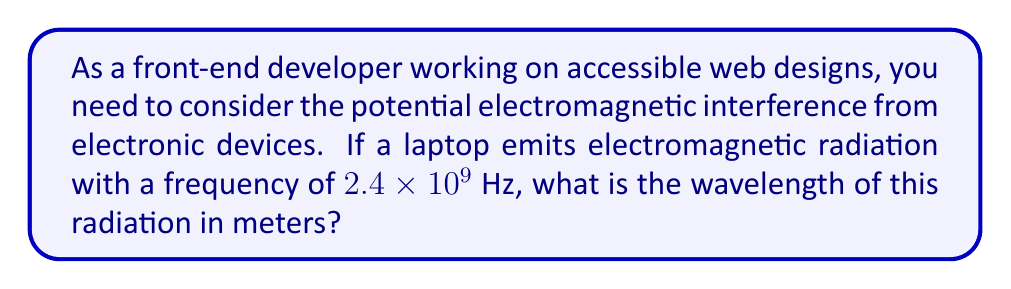What is the answer to this math problem? To solve this problem, we'll use the relationship between wavelength, frequency, and the speed of light:

1) The equation relating wavelength ($\lambda$), frequency ($f$), and speed of light ($c$) is:

   $$c = f\lambda$$

2) We know the speed of light in vacuum is approximately:
   
   $$c = 3 \times 10^8 \text{ m/s}$$

3) The frequency given in the problem is:
   
   $$f = 2.4 \times 10^9 \text{ Hz}$$

4) Rearranging the equation to solve for wavelength:

   $$\lambda = \frac{c}{f}$$

5) Substituting the known values:

   $$\lambda = \frac{3 \times 10^8 \text{ m/s}}{2.4 \times 10^9 \text{ Hz}}$$

6) Simplifying:

   $$\lambda = \frac{3}{2.4} \times \frac{10^8}{10^9} = 0.125 \text{ m}$$

Therefore, the wavelength of the electromagnetic radiation emitted by the laptop is 0.125 meters or 12.5 centimeters.
Answer: $0.125 \text{ m}$ 